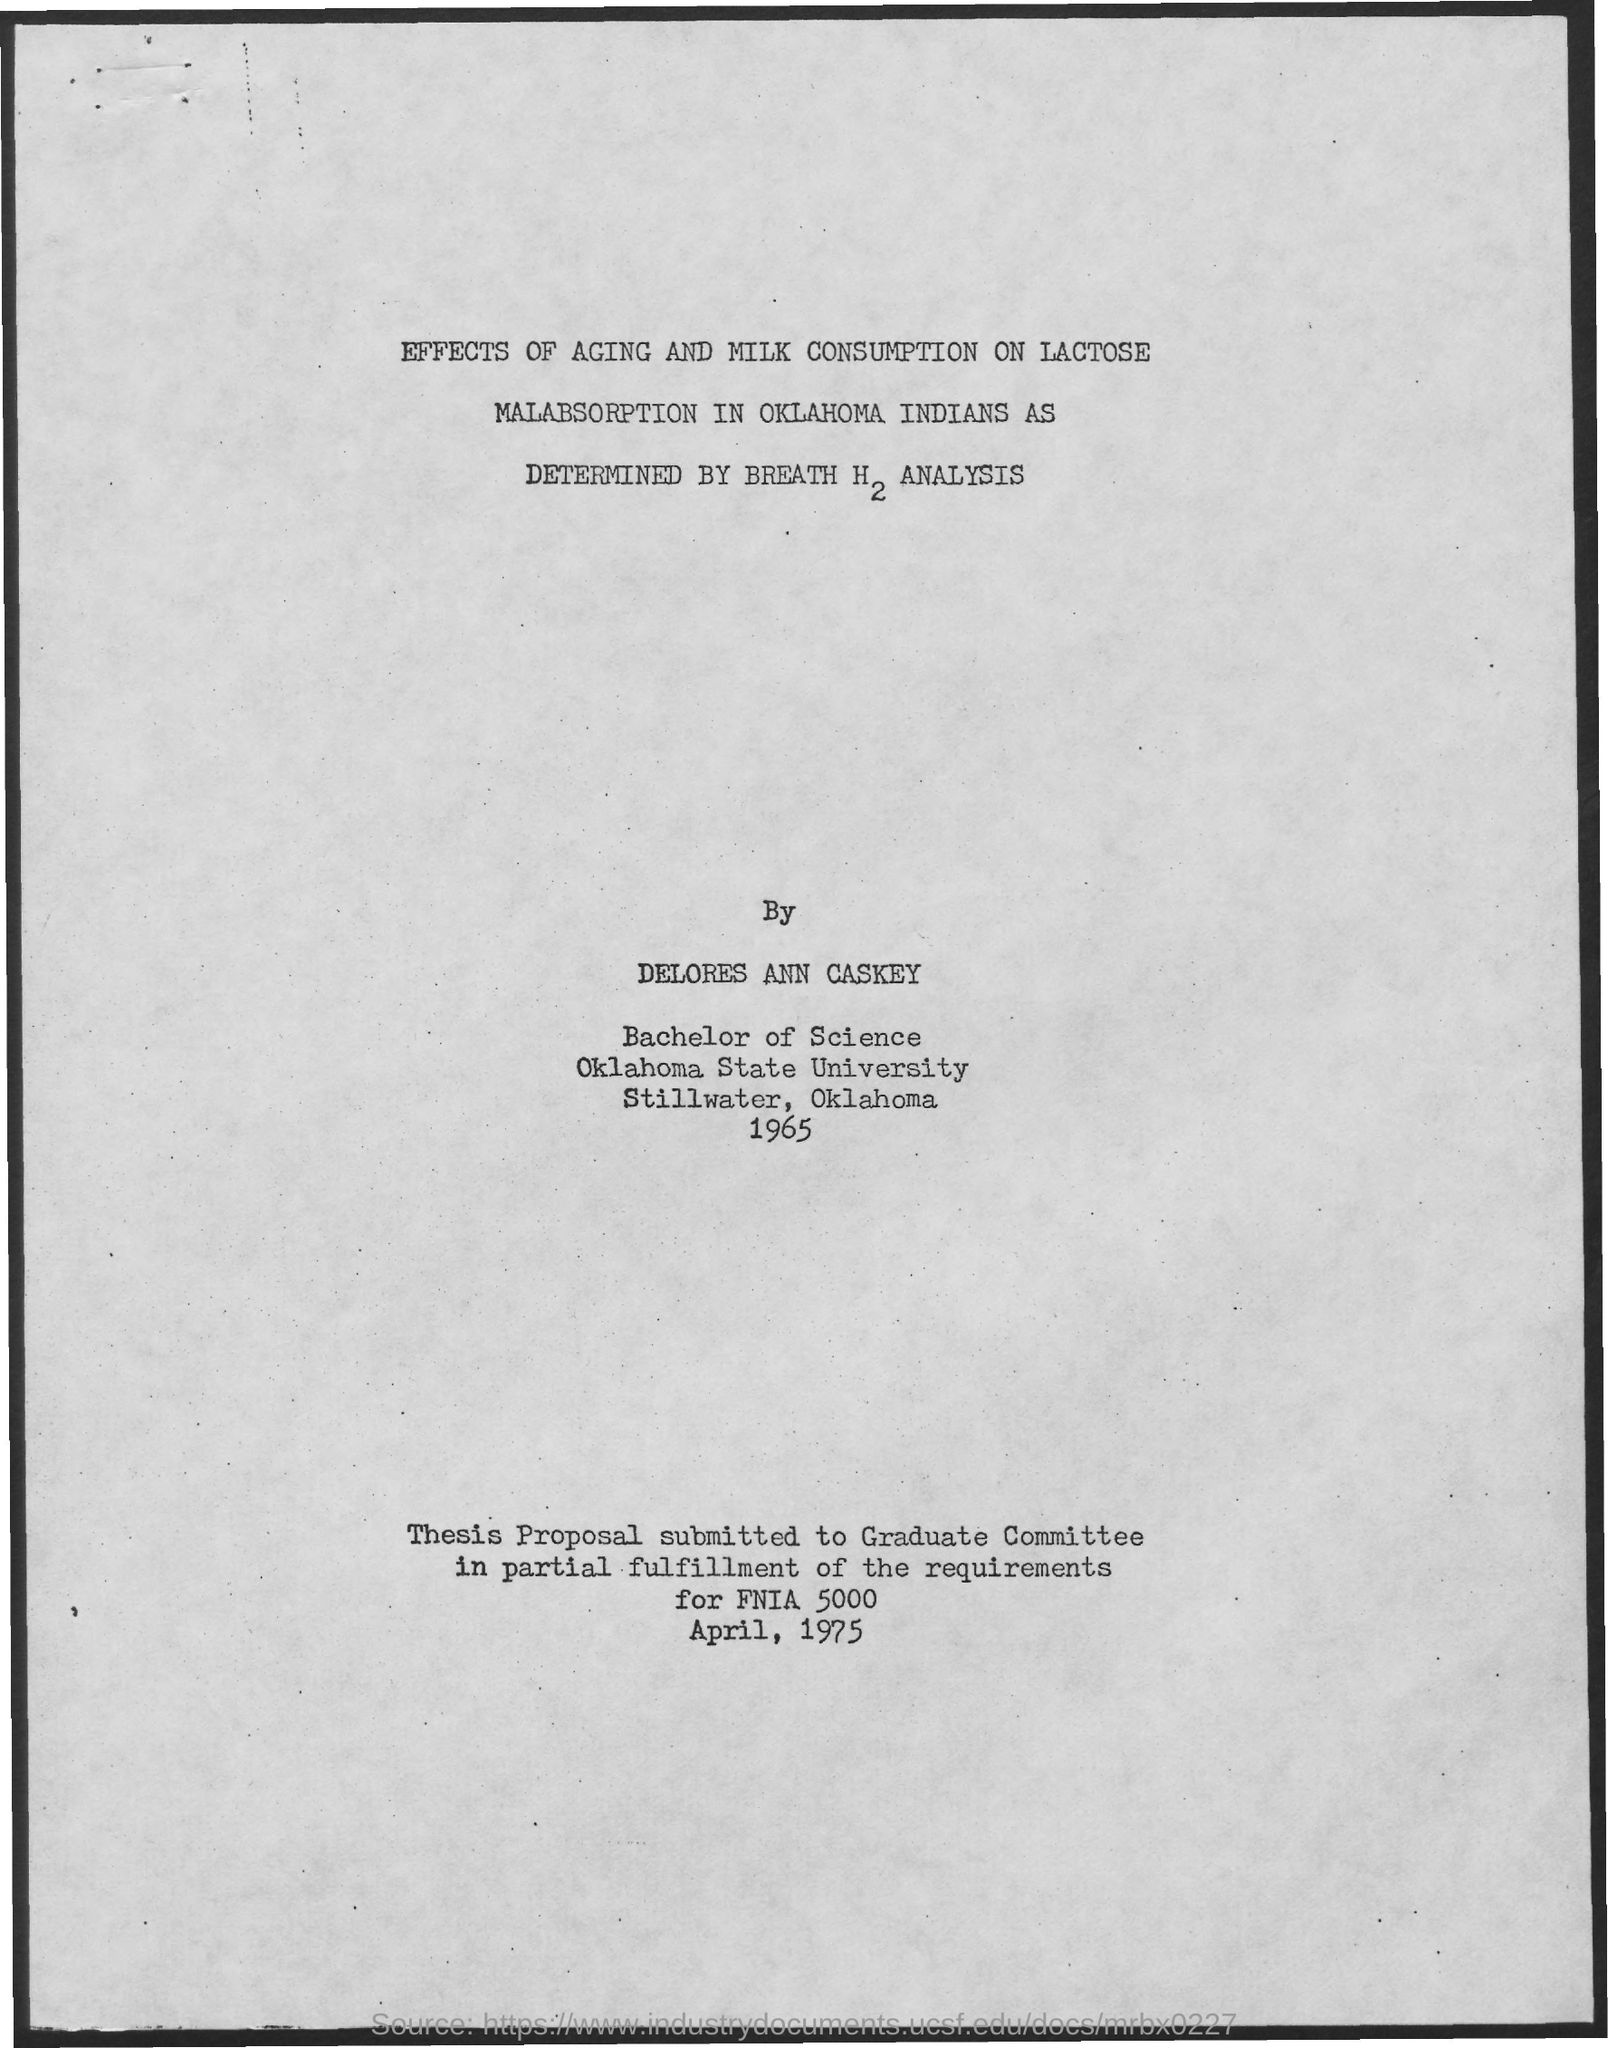To whom is the Thesis proposal submitted to?
Your response must be concise. GRADUATE COMMITTEE. Thesis proposal submitted to the Graduate Committee in partial fulfillment of the requirements for what?
Ensure brevity in your answer.  FNIA 5000. 